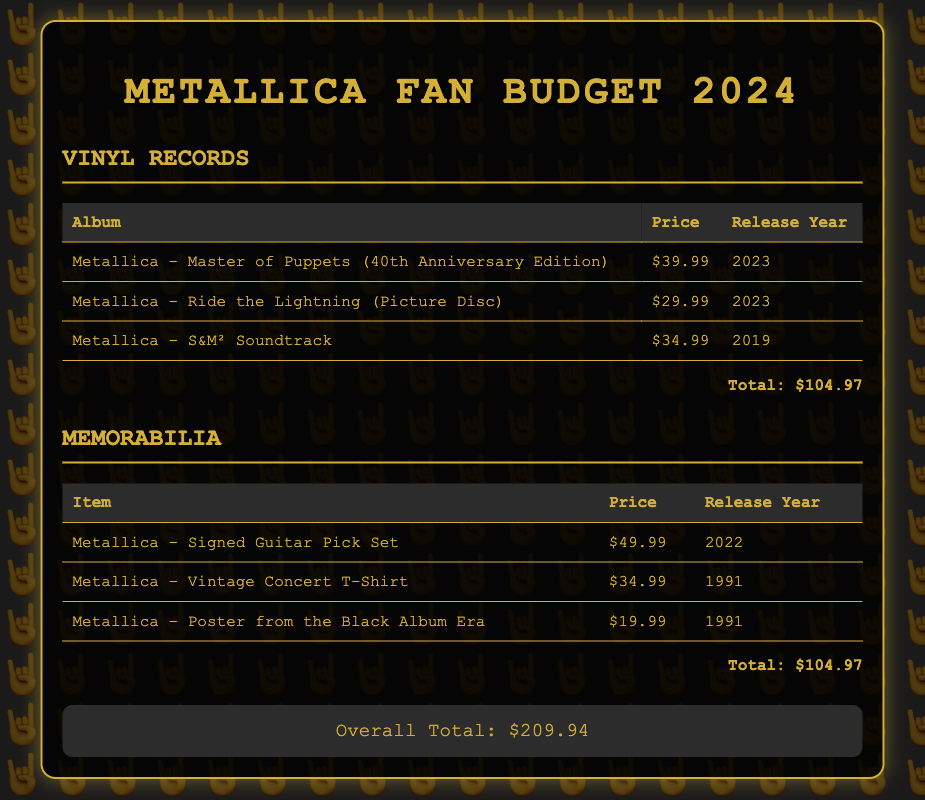what is the total budget for vinyl records? The total budget for vinyl records is listed at the bottom of that section, which is $104.97.
Answer: $104.97 how much is the Metallica - Ride the Lightning (Picture Disc)? The price for the Metallica - Ride the Lightning (Picture Disc) is detailed in the table under vinyl records, which is $29.99.
Answer: $29.99 which memorabilia item is the most expensive? By comparing the prices in the memorabilia section, the most expensive item is the Metallica - Signed Guitar Pick Set at $49.99.
Answer: Metallica - Signed Guitar Pick Set when was the Metallica - Vintage Concert T-Shirt released? The release year for the Metallica - Vintage Concert T-Shirt is provided in the memorabilia table, which is 1991.
Answer: 1991 how many items are listed under vinyl records? The number of items can be counted in the vinyl records table, which lists 3 items.
Answer: 3 what is the overall total for the budget? The overall total is shown at the bottom of the document and is the combined total of both the vinyl records and memorabilia categories, which is $209.94.
Answer: $209.94 which album has a price of $34.99? The $34.99 price is mentioned for the Metallica - S&M² Soundtrack in the vinyl records section.
Answer: Metallica - S&M² Soundtrack what year was the Metallica - Poster from the Black Album Era released? The release year for the Metallica - Poster from the Black Album Era can be found in the memorabilia table, which is 1991.
Answer: 1991 what is the total budget for memorabilia? The total budget for memorabilia is provided at the end of that section, which indicates the total as $104.97.
Answer: $104.97 